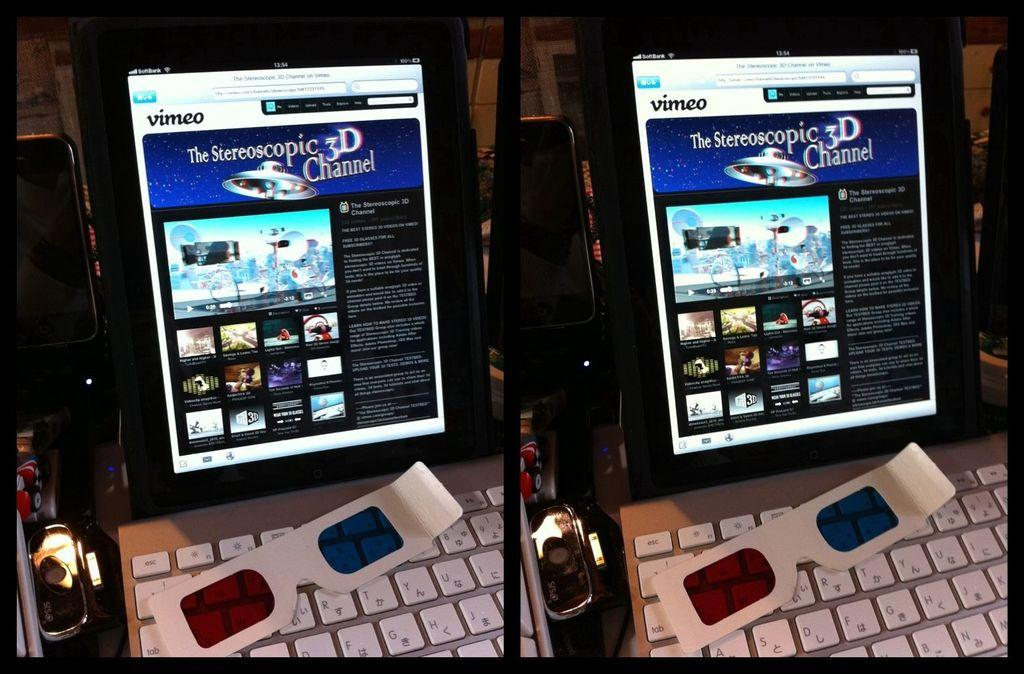<image>
Share a concise interpretation of the image provided. A computer with 3D glasses on the keyboard says Vimeo. 